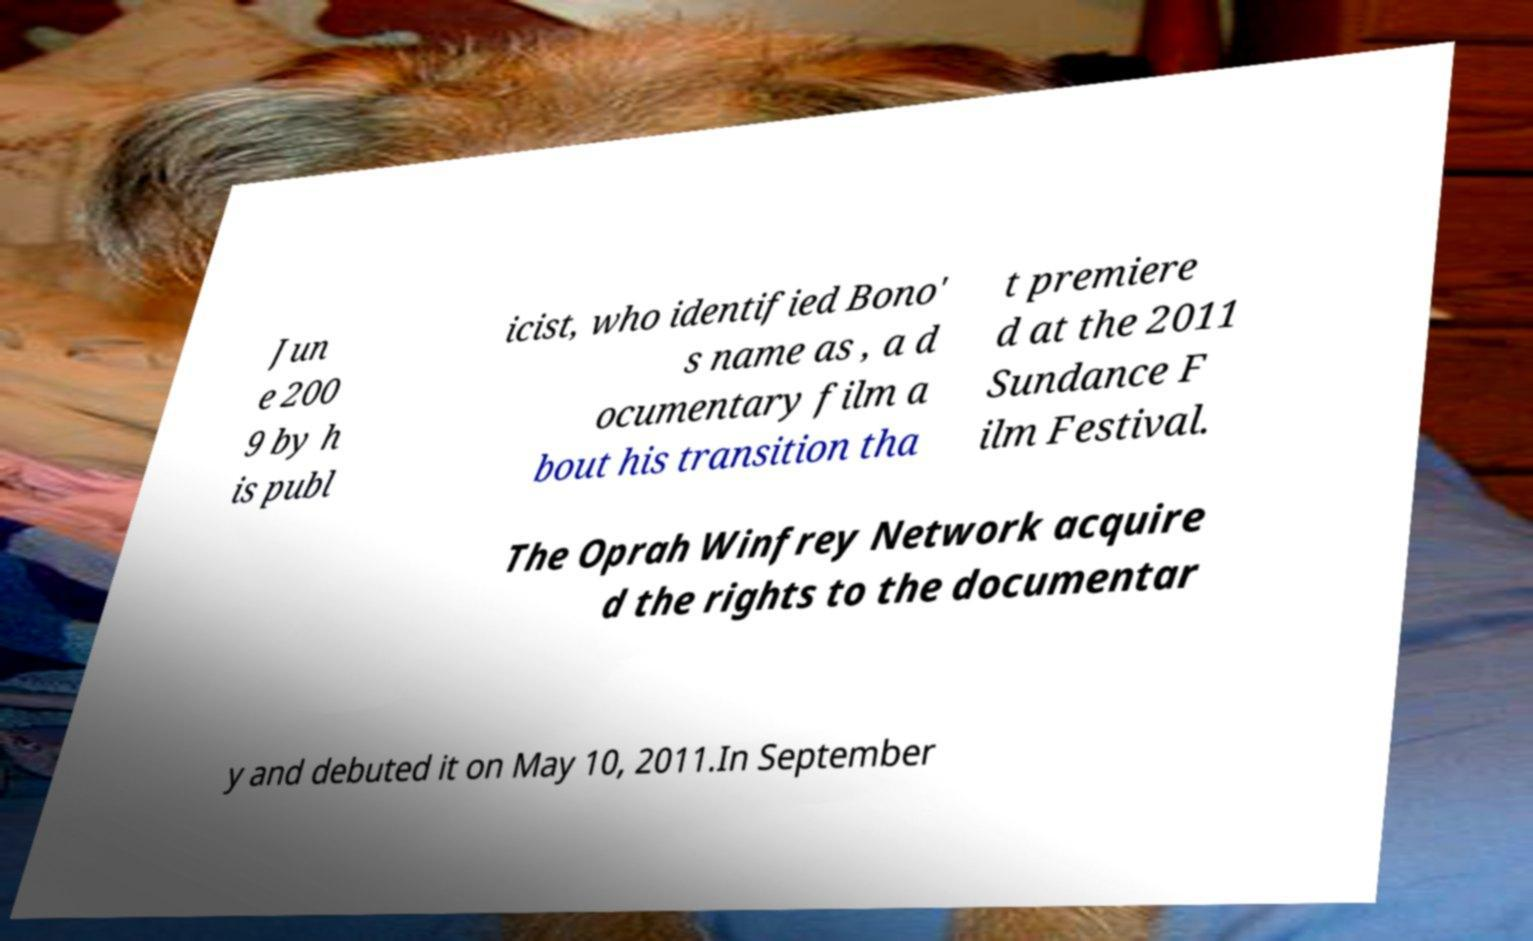There's text embedded in this image that I need extracted. Can you transcribe it verbatim? Jun e 200 9 by h is publ icist, who identified Bono' s name as , a d ocumentary film a bout his transition tha t premiere d at the 2011 Sundance F ilm Festival. The Oprah Winfrey Network acquire d the rights to the documentar y and debuted it on May 10, 2011.In September 